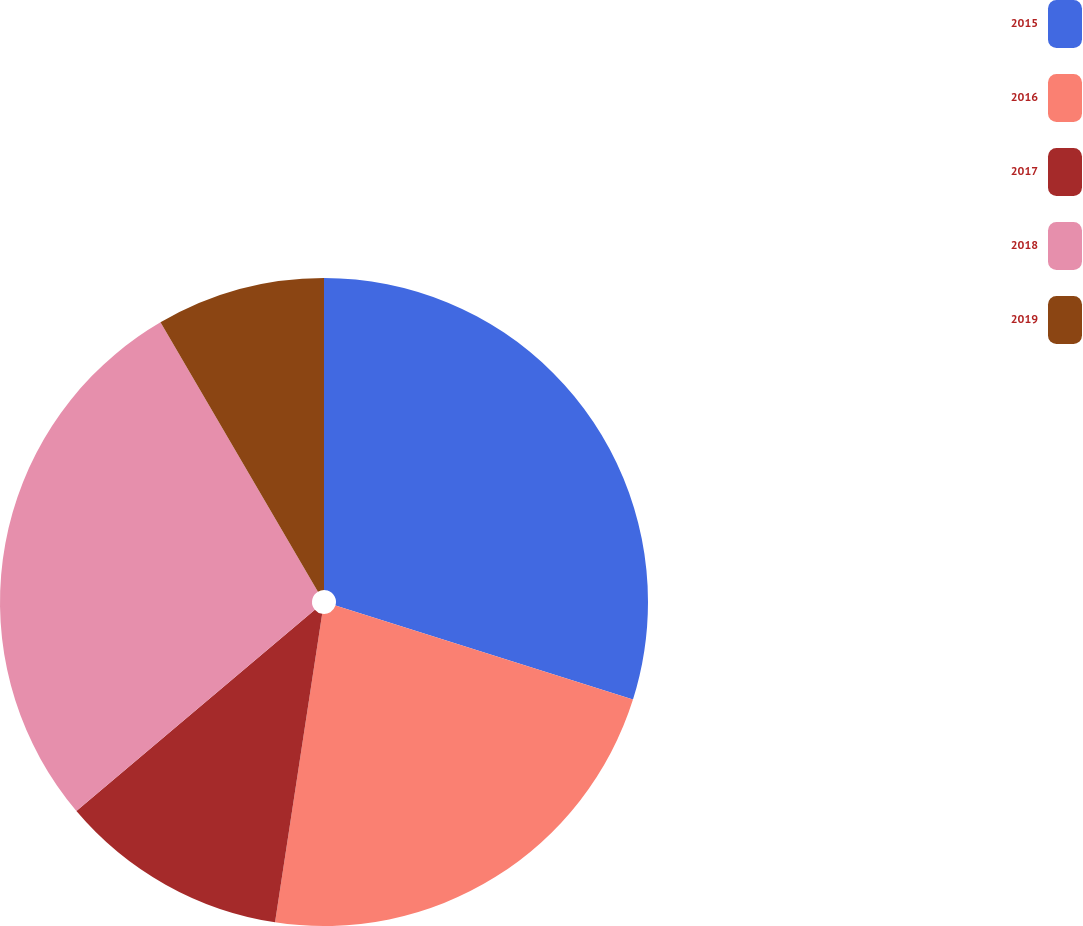Convert chart to OTSL. <chart><loc_0><loc_0><loc_500><loc_500><pie_chart><fcel>2015<fcel>2016<fcel>2017<fcel>2018<fcel>2019<nl><fcel>29.87%<fcel>22.55%<fcel>11.43%<fcel>27.74%<fcel>8.42%<nl></chart> 